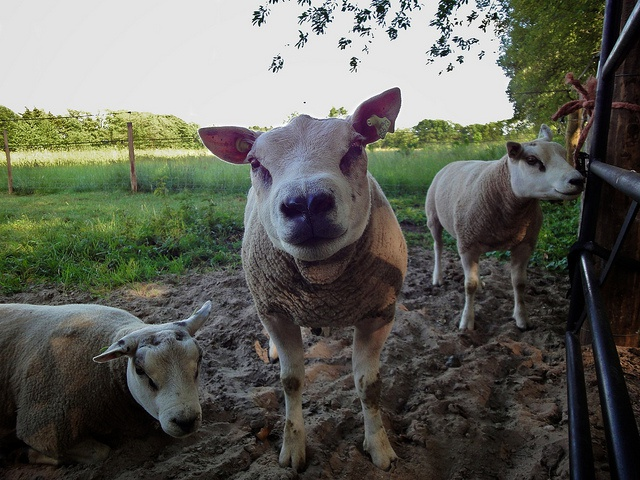Describe the objects in this image and their specific colors. I can see sheep in lightgray, black, gray, and darkgray tones, sheep in lightgray, black, gray, and darkgray tones, and sheep in lightgray, black, gray, and darkgray tones in this image. 